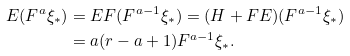Convert formula to latex. <formula><loc_0><loc_0><loc_500><loc_500>E ( F ^ { a } \xi _ { * } ) & = E F ( F ^ { a - 1 } \xi _ { * } ) = ( H + F E ) ( F ^ { a - 1 } \xi _ { * } ) \\ & = a ( r - a + 1 ) F ^ { a - 1 } \xi _ { * } .</formula> 